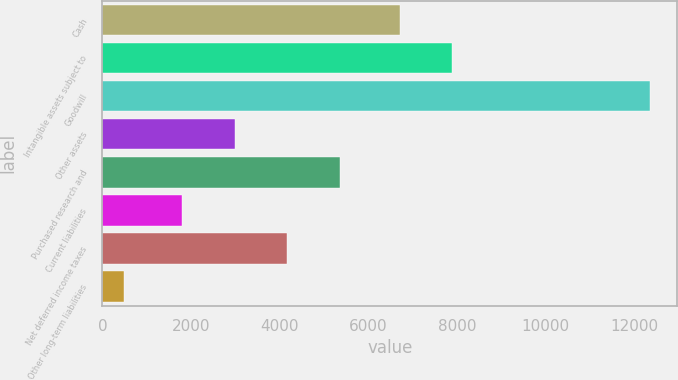Convert chart to OTSL. <chart><loc_0><loc_0><loc_500><loc_500><bar_chart><fcel>Cash<fcel>Intangible assets subject to<fcel>Goodwill<fcel>Other assets<fcel>Purchased research and<fcel>Current liabilities<fcel>Net deferred income taxes<fcel>Other long-term liabilities<nl><fcel>6708<fcel>7893.9<fcel>12354<fcel>2988.9<fcel>5360.7<fcel>1803<fcel>4174.8<fcel>495<nl></chart> 